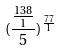<formula> <loc_0><loc_0><loc_500><loc_500>( \frac { \frac { 1 3 8 } { 1 } } { 5 } ) ^ { \frac { 7 7 } { 1 } }</formula> 